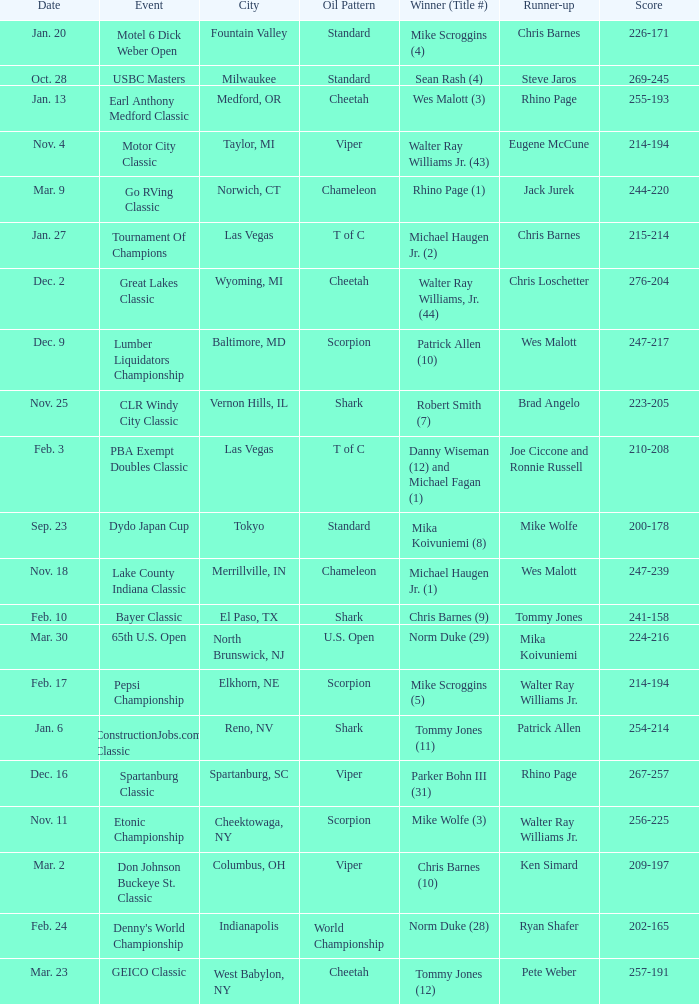What is the happening that has a result of 209-197? Don Johnson Buckeye St. Classic. 